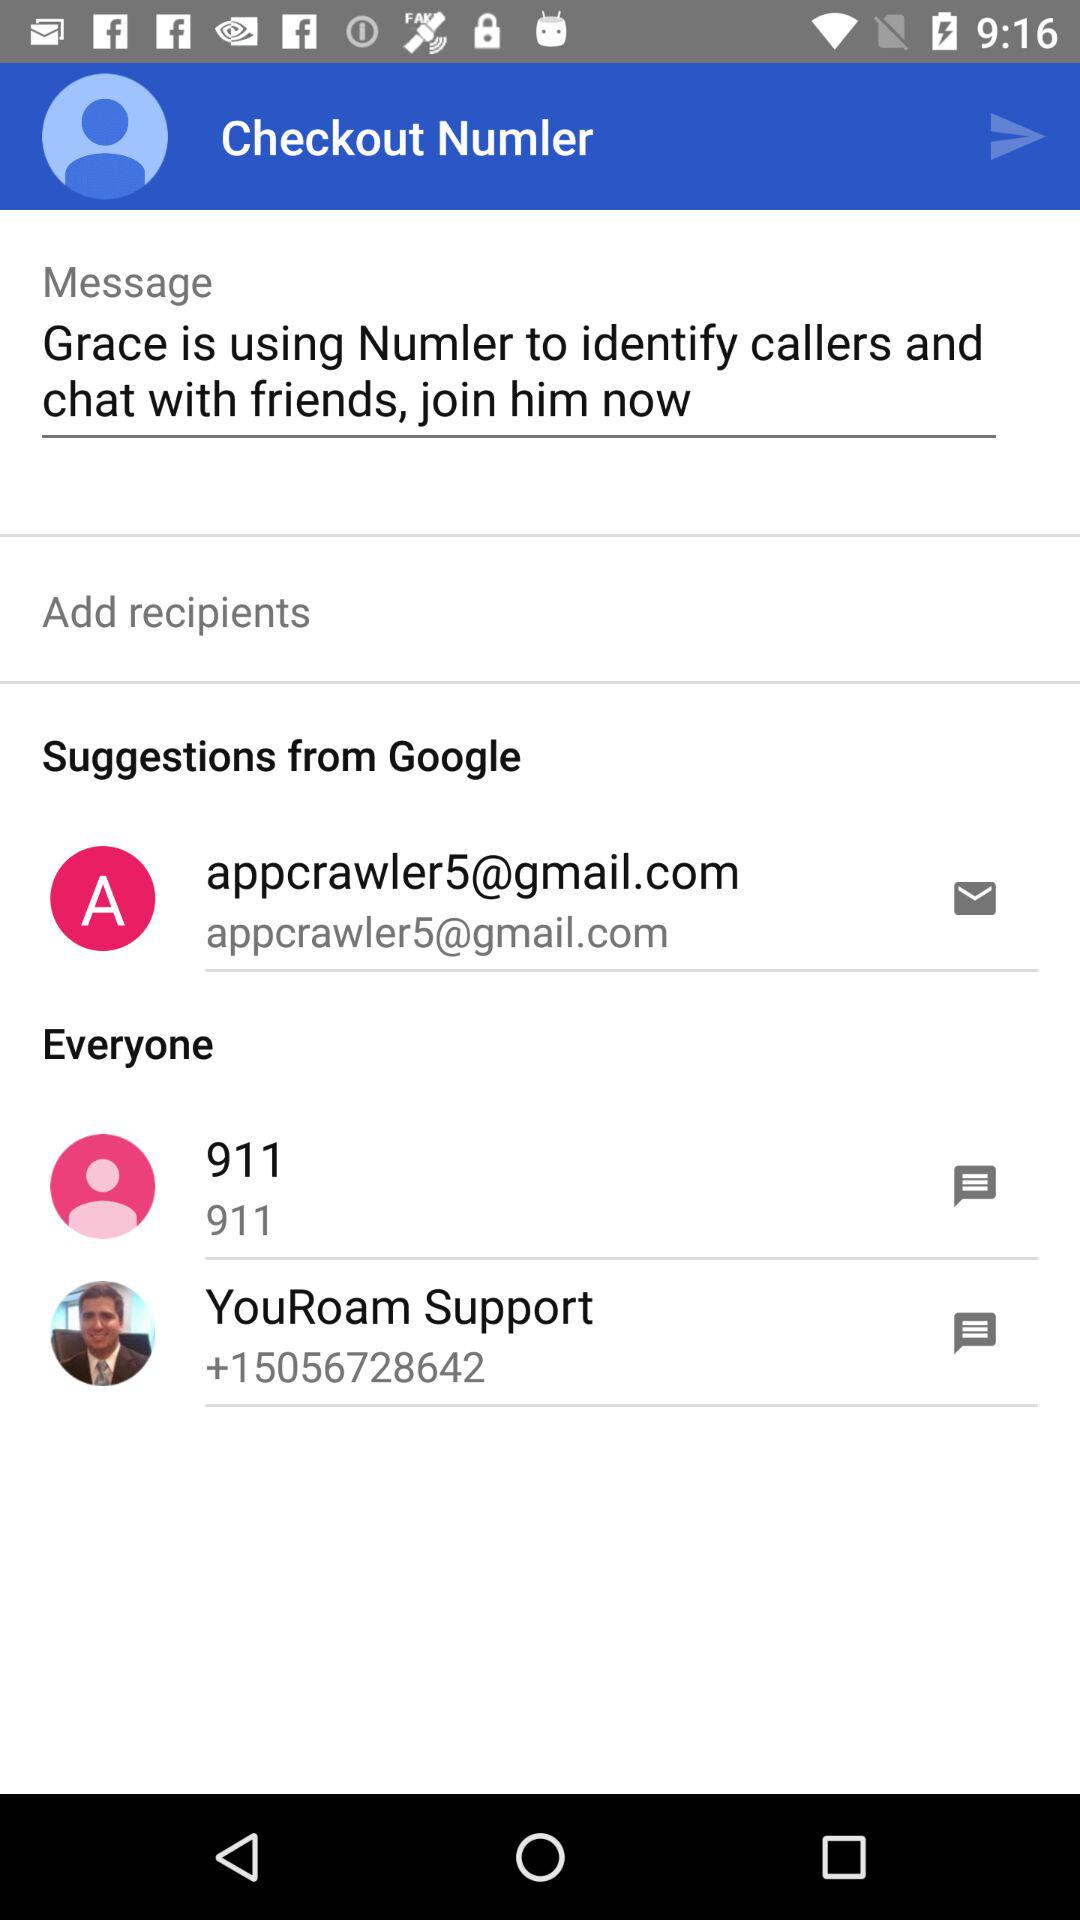What is the name of the Numler user? The name of the Numler user is Grace. 